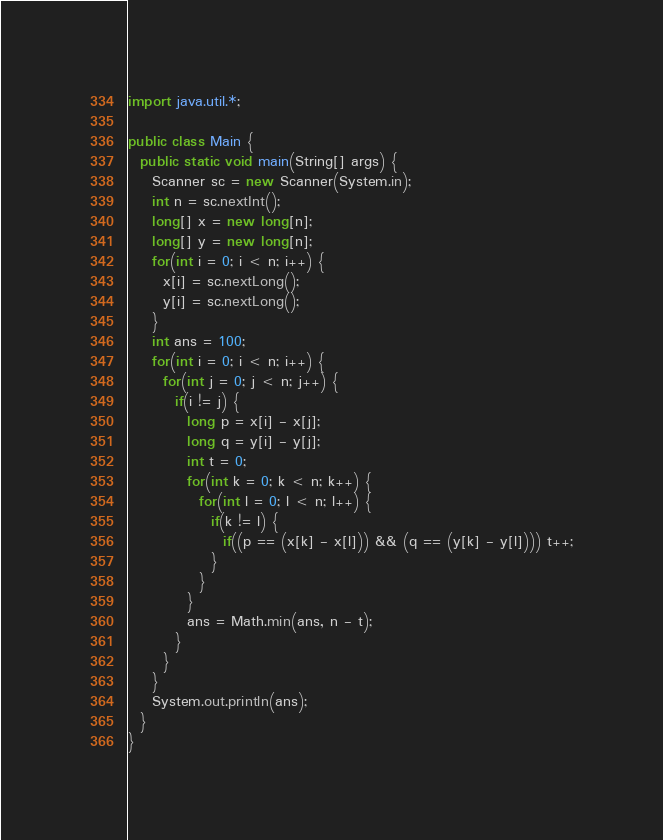Convert code to text. <code><loc_0><loc_0><loc_500><loc_500><_Java_>import java.util.*;

public class Main {
  public static void main(String[] args) {
    Scanner sc = new Scanner(System.in);
    int n = sc.nextInt();
    long[] x = new long[n];
    long[] y = new long[n];
    for(int i = 0; i < n; i++) {
      x[i] = sc.nextLong();
      y[i] = sc.nextLong();
    }
    int ans = 100;
    for(int i = 0; i < n; i++) {
      for(int j = 0; j < n; j++) {
        if(i != j) {
          long p = x[i] - x[j];
          long q = y[i] - y[j];
          int t = 0;
          for(int k = 0; k < n; k++) {
            for(int l = 0; l < n; l++) {
              if(k != l) {
                if((p == (x[k] - x[l])) && (q == (y[k] - y[l]))) t++;
              }
            }
          }
          ans = Math.min(ans, n - t);
        }
      }
    }
    System.out.println(ans);
  }
}</code> 